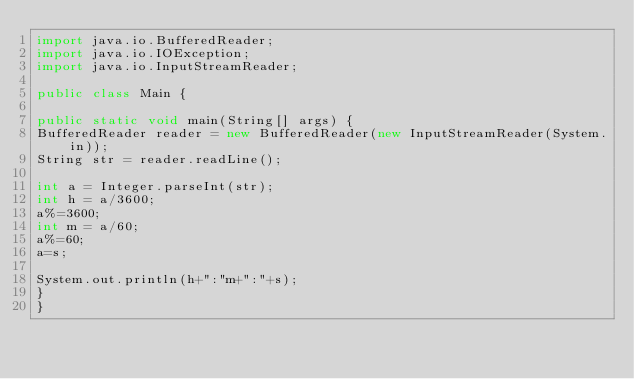<code> <loc_0><loc_0><loc_500><loc_500><_Java_>import java.io.BufferedReader;
import java.io.IOException;
import java.io.InputStreamReader;

public class Main {

public static void main(String[] args) {
BufferedReader reader = new BufferedReader(new InputStreamReader(System.in));
String str = reader.readLine();

int a = Integer.parseInt(str);
int h = a/3600;
a%=3600;
int m = a/60;
a%=60;
a=s;

System.out.println(h+":"m+":"+s);
}
}</code> 